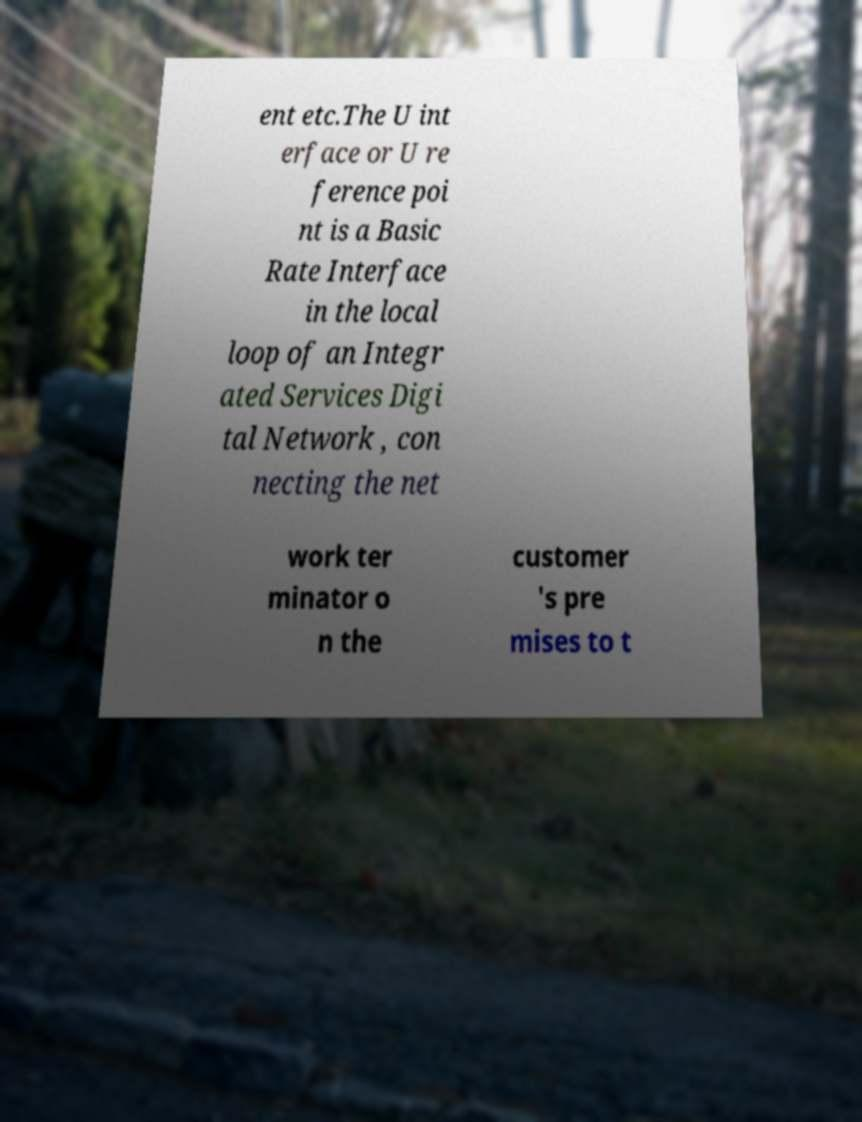Can you read and provide the text displayed in the image?This photo seems to have some interesting text. Can you extract and type it out for me? ent etc.The U int erface or U re ference poi nt is a Basic Rate Interface in the local loop of an Integr ated Services Digi tal Network , con necting the net work ter minator o n the customer 's pre mises to t 